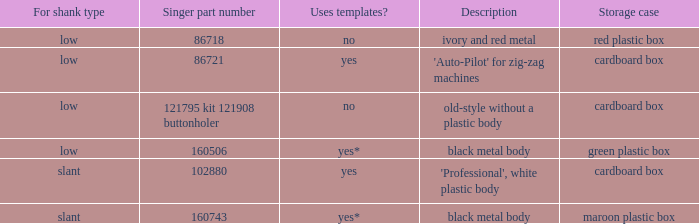What is the description of the buttonholer's storage case made of ivory and red metal? Red plastic box. 